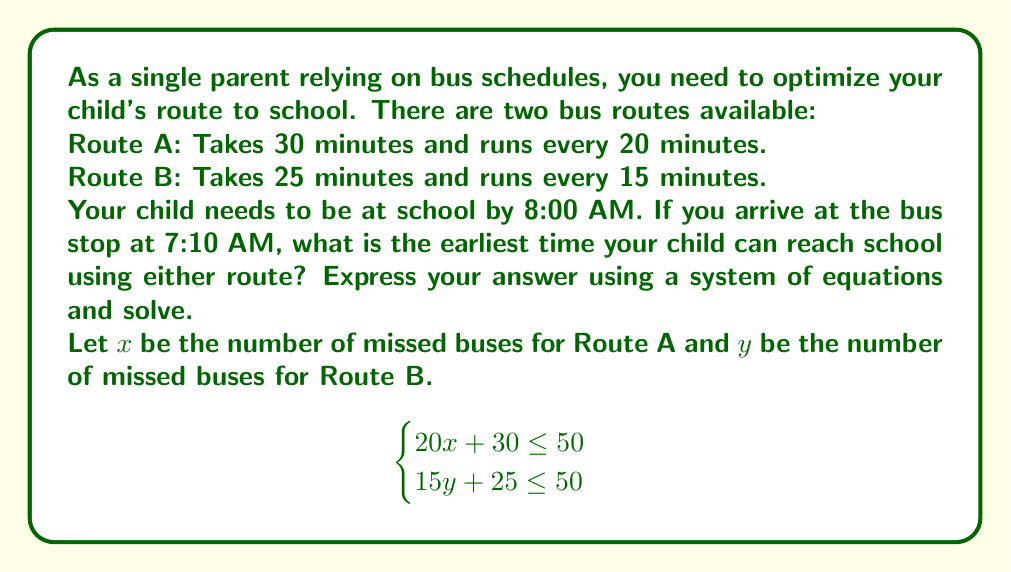Can you answer this question? To solve this problem, we'll follow these steps:

1) First, let's understand what the equations mean:
   - For Route A: $20x + 30 \leq 50$
     $20x$ represents the waiting time (number of missed buses multiplied by the frequency)
     $30$ is the travel time
     $50$ is the total available time (from 7:10 AM to 8:00 AM)
   
   - For Route B: $15y + 25 \leq 50$
     Similar interpretation as Route A

2) Now, we need to find the maximum integer values for $x$ and $y$ that satisfy these inequalities:

   For Route A:
   $$20x + 30 \leq 50$$
   $$20x \leq 20$$
   $$x \leq 1$$
   The maximum integer value for $x$ is 1.

   For Route B:
   $$15y + 25 \leq 50$$
   $$15y \leq 25$$
   $$y \leq 1.67$$
   The maximum integer value for $y$ is 1.

3) This means:
   - For Route A, you can miss at most 1 bus
   - For Route B, you can miss at most 1 bus

4) Now, let's calculate the arrival times:
   
   Route A: 7:10 AM + 20 min (1 missed bus) + 30 min (travel time) = 8:00 AM
   Route B: 7:10 AM + 15 min (1 missed bus) + 25 min (travel time) = 7:50 AM

5) Therefore, the earliest arrival time is 7:50 AM using Route B.
Answer: The earliest time your child can reach school is 7:50 AM, using Route B. 